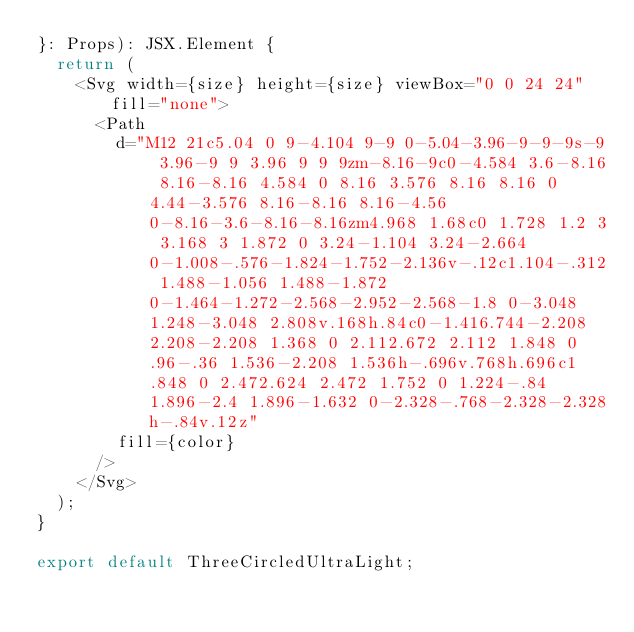Convert code to text. <code><loc_0><loc_0><loc_500><loc_500><_TypeScript_>}: Props): JSX.Element {
  return (
    <Svg width={size} height={size} viewBox="0 0 24 24" fill="none">
      <Path
        d="M12 21c5.04 0 9-4.104 9-9 0-5.04-3.96-9-9-9s-9 3.96-9 9 3.96 9 9 9zm-8.16-9c0-4.584 3.6-8.16 8.16-8.16 4.584 0 8.16 3.576 8.16 8.16 0 4.44-3.576 8.16-8.16 8.16-4.56 0-8.16-3.6-8.16-8.16zm4.968 1.68c0 1.728 1.2 3 3.168 3 1.872 0 3.24-1.104 3.24-2.664 0-1.008-.576-1.824-1.752-2.136v-.12c1.104-.312 1.488-1.056 1.488-1.872 0-1.464-1.272-2.568-2.952-2.568-1.8 0-3.048 1.248-3.048 2.808v.168h.84c0-1.416.744-2.208 2.208-2.208 1.368 0 2.112.672 2.112 1.848 0 .96-.36 1.536-2.208 1.536h-.696v.768h.696c1.848 0 2.472.624 2.472 1.752 0 1.224-.84 1.896-2.4 1.896-1.632 0-2.328-.768-2.328-2.328h-.84v.12z"
        fill={color}
      />
    </Svg>
  );
}

export default ThreeCircledUltraLight;
</code> 